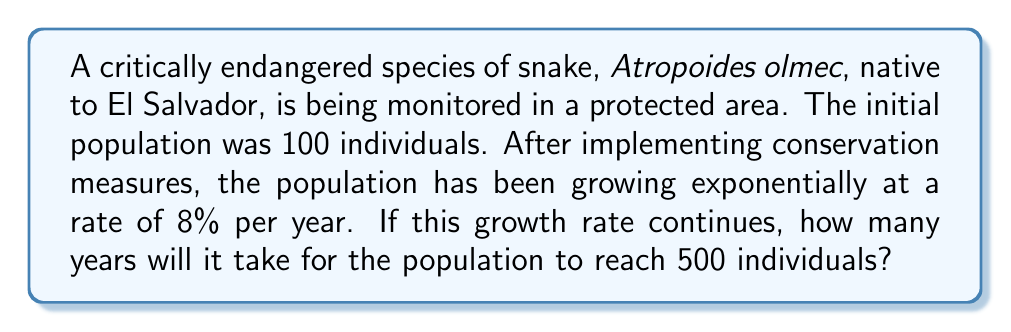Provide a solution to this math problem. To solve this problem, we'll use the exponential growth function and logarithms:

1) The exponential growth function is given by:
   $$P(t) = P_0 \cdot e^{rt}$$
   where $P(t)$ is the population at time $t$, $P_0$ is the initial population, $r$ is the growth rate, and $t$ is time.

2) We know:
   $P_0 = 100$ (initial population)
   $r = 0.08$ (8% growth rate per year)
   $P(t) = 500$ (target population)

3) Substituting these values into the equation:
   $$500 = 100 \cdot e^{0.08t}$$

4) Divide both sides by 100:
   $$5 = e^{0.08t}$$

5) Take the natural logarithm of both sides:
   $$\ln(5) = 0.08t$$

6) Solve for $t$:
   $$t = \frac{\ln(5)}{0.08}$$

7) Calculate the result:
   $$t = \frac{1.6094...}{0.08} \approx 20.1175...$$

8) Since we can only have whole years, we round up to the next integer.
Answer: 21 years 